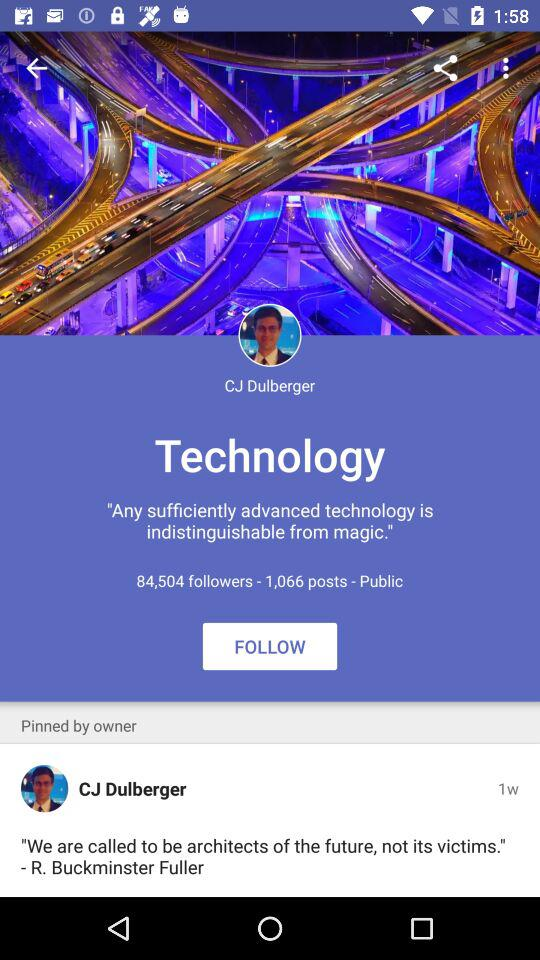What is the profile setting?
When the provided information is insufficient, respond with <no answer>. <no answer> 